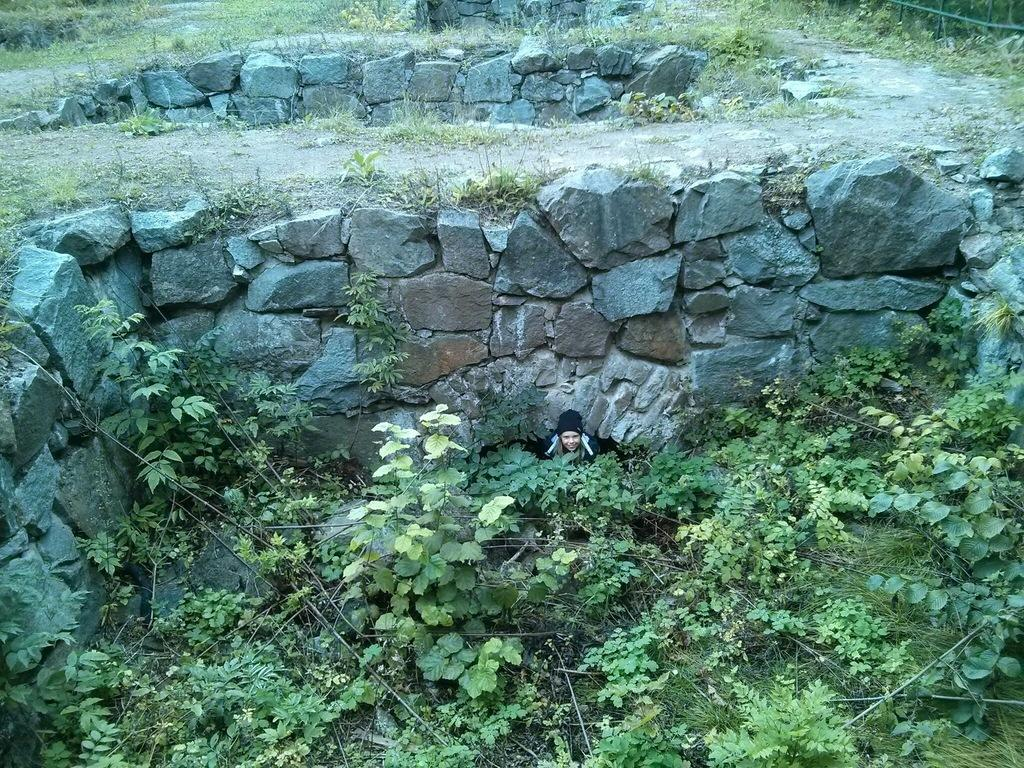What is the person in the image doing? The person is sitting in the image. Where is the person sitting? The person is sitting between trees. What is visible behind the person? There is a stone wall behind the person. What type of vegetation can be seen in the image? Plants and trees are visible in the image. What material is present in the image? Stones are present in the image. What advice does the cabbage give to the person in the image? There is no cabbage present in the image, and therefore no advice can be given. 